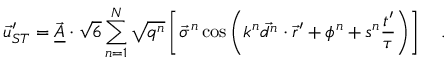<formula> <loc_0><loc_0><loc_500><loc_500>\vec { u } _ { S T } ^ { \prime } = \vec { \underline { A } } \cdot \sqrt { 6 } \sum _ { n = 1 } ^ { N } \sqrt { q ^ { n } } \left [ \vec { \sigma } ^ { n } \cos \left ( k ^ { n } \vec { d ^ { n } } \cdot \vec { r } ^ { \prime } + \phi ^ { n } + s ^ { n } \frac { t ^ { \prime } } { \tau } \right ) \right ] \quad .</formula> 